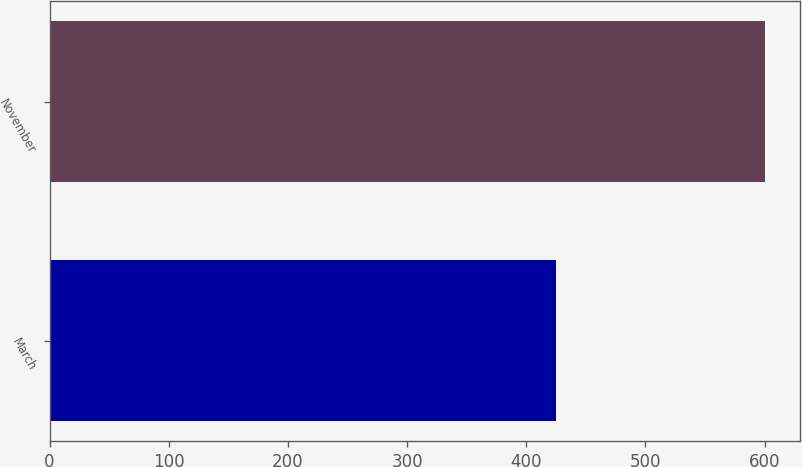Convert chart to OTSL. <chart><loc_0><loc_0><loc_500><loc_500><bar_chart><fcel>March<fcel>November<nl><fcel>425<fcel>600<nl></chart> 